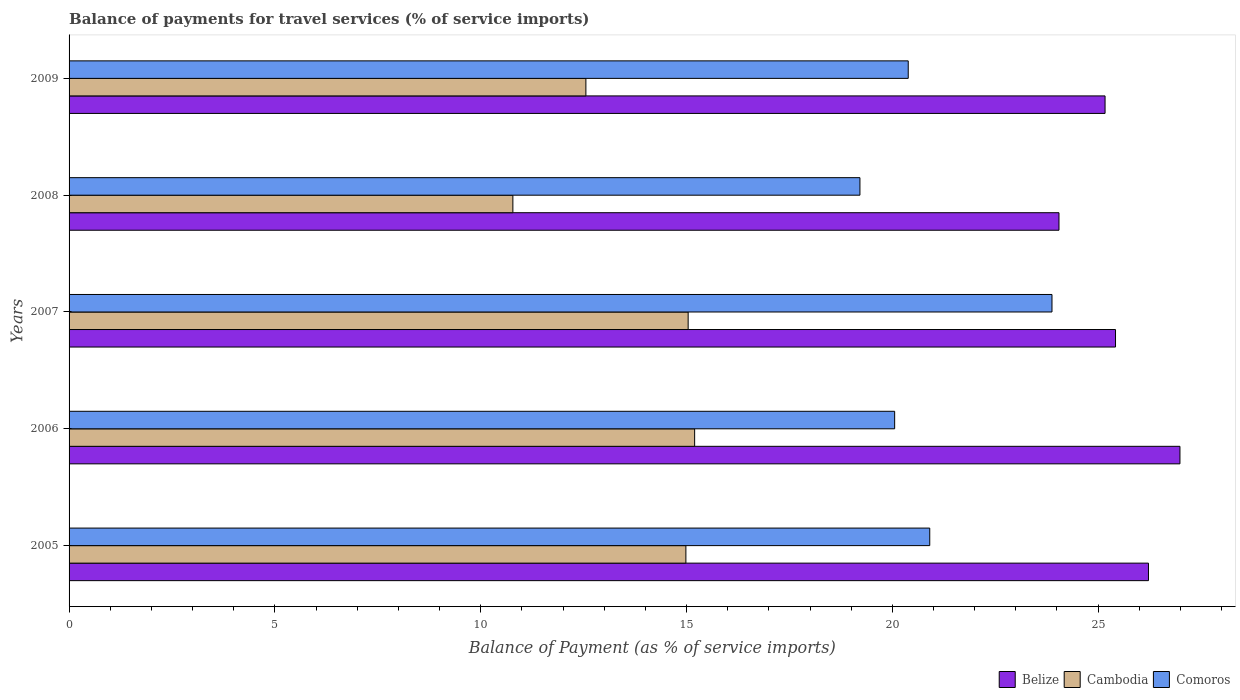Are the number of bars per tick equal to the number of legend labels?
Offer a terse response. Yes. Are the number of bars on each tick of the Y-axis equal?
Make the answer very short. Yes. How many bars are there on the 4th tick from the top?
Give a very brief answer. 3. What is the label of the 4th group of bars from the top?
Make the answer very short. 2006. What is the balance of payments for travel services in Comoros in 2006?
Keep it short and to the point. 20.06. Across all years, what is the maximum balance of payments for travel services in Belize?
Offer a very short reply. 26.99. Across all years, what is the minimum balance of payments for travel services in Belize?
Your response must be concise. 24.05. In which year was the balance of payments for travel services in Belize maximum?
Ensure brevity in your answer.  2006. What is the total balance of payments for travel services in Comoros in the graph?
Offer a very short reply. 104.44. What is the difference between the balance of payments for travel services in Cambodia in 2005 and that in 2009?
Provide a succinct answer. 2.43. What is the difference between the balance of payments for travel services in Cambodia in 2005 and the balance of payments for travel services in Belize in 2009?
Offer a terse response. -10.18. What is the average balance of payments for travel services in Belize per year?
Make the answer very short. 25.57. In the year 2008, what is the difference between the balance of payments for travel services in Comoros and balance of payments for travel services in Cambodia?
Offer a very short reply. 8.43. What is the ratio of the balance of payments for travel services in Belize in 2005 to that in 2009?
Provide a short and direct response. 1.04. Is the balance of payments for travel services in Comoros in 2005 less than that in 2008?
Your response must be concise. No. What is the difference between the highest and the second highest balance of payments for travel services in Cambodia?
Keep it short and to the point. 0.16. What is the difference between the highest and the lowest balance of payments for travel services in Cambodia?
Keep it short and to the point. 4.42. In how many years, is the balance of payments for travel services in Belize greater than the average balance of payments for travel services in Belize taken over all years?
Keep it short and to the point. 2. Is the sum of the balance of payments for travel services in Cambodia in 2006 and 2008 greater than the maximum balance of payments for travel services in Comoros across all years?
Your answer should be very brief. Yes. What does the 3rd bar from the top in 2007 represents?
Offer a very short reply. Belize. What does the 1st bar from the bottom in 2008 represents?
Ensure brevity in your answer.  Belize. Is it the case that in every year, the sum of the balance of payments for travel services in Cambodia and balance of payments for travel services in Comoros is greater than the balance of payments for travel services in Belize?
Your response must be concise. Yes. How many bars are there?
Make the answer very short. 15. Are all the bars in the graph horizontal?
Provide a short and direct response. Yes. What is the difference between two consecutive major ticks on the X-axis?
Provide a succinct answer. 5. Are the values on the major ticks of X-axis written in scientific E-notation?
Offer a terse response. No. Does the graph contain any zero values?
Give a very brief answer. No. How many legend labels are there?
Keep it short and to the point. 3. How are the legend labels stacked?
Keep it short and to the point. Horizontal. What is the title of the graph?
Your answer should be compact. Balance of payments for travel services (% of service imports). What is the label or title of the X-axis?
Your answer should be very brief. Balance of Payment (as % of service imports). What is the Balance of Payment (as % of service imports) of Belize in 2005?
Your answer should be compact. 26.22. What is the Balance of Payment (as % of service imports) of Cambodia in 2005?
Offer a terse response. 14.98. What is the Balance of Payment (as % of service imports) in Comoros in 2005?
Provide a short and direct response. 20.91. What is the Balance of Payment (as % of service imports) of Belize in 2006?
Your response must be concise. 26.99. What is the Balance of Payment (as % of service imports) of Cambodia in 2006?
Provide a succinct answer. 15.2. What is the Balance of Payment (as % of service imports) in Comoros in 2006?
Offer a very short reply. 20.06. What is the Balance of Payment (as % of service imports) of Belize in 2007?
Provide a short and direct response. 25.42. What is the Balance of Payment (as % of service imports) of Cambodia in 2007?
Your answer should be compact. 15.04. What is the Balance of Payment (as % of service imports) in Comoros in 2007?
Offer a terse response. 23.88. What is the Balance of Payment (as % of service imports) of Belize in 2008?
Give a very brief answer. 24.05. What is the Balance of Payment (as % of service imports) of Cambodia in 2008?
Ensure brevity in your answer.  10.78. What is the Balance of Payment (as % of service imports) of Comoros in 2008?
Your answer should be very brief. 19.21. What is the Balance of Payment (as % of service imports) in Belize in 2009?
Ensure brevity in your answer.  25.17. What is the Balance of Payment (as % of service imports) of Cambodia in 2009?
Make the answer very short. 12.56. What is the Balance of Payment (as % of service imports) of Comoros in 2009?
Provide a short and direct response. 20.39. Across all years, what is the maximum Balance of Payment (as % of service imports) of Belize?
Your response must be concise. 26.99. Across all years, what is the maximum Balance of Payment (as % of service imports) of Cambodia?
Your response must be concise. 15.2. Across all years, what is the maximum Balance of Payment (as % of service imports) of Comoros?
Provide a short and direct response. 23.88. Across all years, what is the minimum Balance of Payment (as % of service imports) of Belize?
Your answer should be very brief. 24.05. Across all years, what is the minimum Balance of Payment (as % of service imports) of Cambodia?
Your answer should be very brief. 10.78. Across all years, what is the minimum Balance of Payment (as % of service imports) in Comoros?
Offer a very short reply. 19.21. What is the total Balance of Payment (as % of service imports) in Belize in the graph?
Offer a terse response. 127.85. What is the total Balance of Payment (as % of service imports) in Cambodia in the graph?
Offer a terse response. 68.56. What is the total Balance of Payment (as % of service imports) in Comoros in the graph?
Provide a succinct answer. 104.44. What is the difference between the Balance of Payment (as % of service imports) of Belize in 2005 and that in 2006?
Keep it short and to the point. -0.76. What is the difference between the Balance of Payment (as % of service imports) in Cambodia in 2005 and that in 2006?
Offer a terse response. -0.21. What is the difference between the Balance of Payment (as % of service imports) of Comoros in 2005 and that in 2006?
Provide a short and direct response. 0.85. What is the difference between the Balance of Payment (as % of service imports) in Belize in 2005 and that in 2007?
Your answer should be compact. 0.8. What is the difference between the Balance of Payment (as % of service imports) of Cambodia in 2005 and that in 2007?
Your answer should be compact. -0.06. What is the difference between the Balance of Payment (as % of service imports) of Comoros in 2005 and that in 2007?
Provide a succinct answer. -2.97. What is the difference between the Balance of Payment (as % of service imports) in Belize in 2005 and that in 2008?
Your answer should be compact. 2.17. What is the difference between the Balance of Payment (as % of service imports) of Cambodia in 2005 and that in 2008?
Ensure brevity in your answer.  4.2. What is the difference between the Balance of Payment (as % of service imports) in Comoros in 2005 and that in 2008?
Offer a very short reply. 1.7. What is the difference between the Balance of Payment (as % of service imports) of Belize in 2005 and that in 2009?
Offer a very short reply. 1.05. What is the difference between the Balance of Payment (as % of service imports) in Cambodia in 2005 and that in 2009?
Your answer should be compact. 2.43. What is the difference between the Balance of Payment (as % of service imports) in Comoros in 2005 and that in 2009?
Keep it short and to the point. 0.52. What is the difference between the Balance of Payment (as % of service imports) in Belize in 2006 and that in 2007?
Provide a short and direct response. 1.57. What is the difference between the Balance of Payment (as % of service imports) in Cambodia in 2006 and that in 2007?
Keep it short and to the point. 0.16. What is the difference between the Balance of Payment (as % of service imports) in Comoros in 2006 and that in 2007?
Provide a succinct answer. -3.82. What is the difference between the Balance of Payment (as % of service imports) of Belize in 2006 and that in 2008?
Make the answer very short. 2.94. What is the difference between the Balance of Payment (as % of service imports) in Cambodia in 2006 and that in 2008?
Your response must be concise. 4.42. What is the difference between the Balance of Payment (as % of service imports) of Comoros in 2006 and that in 2008?
Your answer should be compact. 0.84. What is the difference between the Balance of Payment (as % of service imports) of Belize in 2006 and that in 2009?
Provide a succinct answer. 1.82. What is the difference between the Balance of Payment (as % of service imports) in Cambodia in 2006 and that in 2009?
Ensure brevity in your answer.  2.64. What is the difference between the Balance of Payment (as % of service imports) of Comoros in 2006 and that in 2009?
Make the answer very short. -0.33. What is the difference between the Balance of Payment (as % of service imports) in Belize in 2007 and that in 2008?
Offer a very short reply. 1.37. What is the difference between the Balance of Payment (as % of service imports) of Cambodia in 2007 and that in 2008?
Your response must be concise. 4.26. What is the difference between the Balance of Payment (as % of service imports) in Comoros in 2007 and that in 2008?
Offer a terse response. 4.67. What is the difference between the Balance of Payment (as % of service imports) of Belize in 2007 and that in 2009?
Your answer should be very brief. 0.25. What is the difference between the Balance of Payment (as % of service imports) in Cambodia in 2007 and that in 2009?
Your answer should be very brief. 2.48. What is the difference between the Balance of Payment (as % of service imports) of Comoros in 2007 and that in 2009?
Your answer should be very brief. 3.49. What is the difference between the Balance of Payment (as % of service imports) of Belize in 2008 and that in 2009?
Your response must be concise. -1.12. What is the difference between the Balance of Payment (as % of service imports) in Cambodia in 2008 and that in 2009?
Keep it short and to the point. -1.77. What is the difference between the Balance of Payment (as % of service imports) in Comoros in 2008 and that in 2009?
Offer a very short reply. -1.17. What is the difference between the Balance of Payment (as % of service imports) of Belize in 2005 and the Balance of Payment (as % of service imports) of Cambodia in 2006?
Provide a succinct answer. 11.03. What is the difference between the Balance of Payment (as % of service imports) in Belize in 2005 and the Balance of Payment (as % of service imports) in Comoros in 2006?
Offer a very short reply. 6.17. What is the difference between the Balance of Payment (as % of service imports) of Cambodia in 2005 and the Balance of Payment (as % of service imports) of Comoros in 2006?
Your answer should be very brief. -5.07. What is the difference between the Balance of Payment (as % of service imports) of Belize in 2005 and the Balance of Payment (as % of service imports) of Cambodia in 2007?
Your answer should be very brief. 11.18. What is the difference between the Balance of Payment (as % of service imports) in Belize in 2005 and the Balance of Payment (as % of service imports) in Comoros in 2007?
Make the answer very short. 2.34. What is the difference between the Balance of Payment (as % of service imports) in Cambodia in 2005 and the Balance of Payment (as % of service imports) in Comoros in 2007?
Offer a terse response. -8.89. What is the difference between the Balance of Payment (as % of service imports) in Belize in 2005 and the Balance of Payment (as % of service imports) in Cambodia in 2008?
Your response must be concise. 15.44. What is the difference between the Balance of Payment (as % of service imports) of Belize in 2005 and the Balance of Payment (as % of service imports) of Comoros in 2008?
Your answer should be compact. 7.01. What is the difference between the Balance of Payment (as % of service imports) in Cambodia in 2005 and the Balance of Payment (as % of service imports) in Comoros in 2008?
Give a very brief answer. -4.23. What is the difference between the Balance of Payment (as % of service imports) in Belize in 2005 and the Balance of Payment (as % of service imports) in Cambodia in 2009?
Give a very brief answer. 13.67. What is the difference between the Balance of Payment (as % of service imports) of Belize in 2005 and the Balance of Payment (as % of service imports) of Comoros in 2009?
Give a very brief answer. 5.84. What is the difference between the Balance of Payment (as % of service imports) in Cambodia in 2005 and the Balance of Payment (as % of service imports) in Comoros in 2009?
Your answer should be compact. -5.4. What is the difference between the Balance of Payment (as % of service imports) of Belize in 2006 and the Balance of Payment (as % of service imports) of Cambodia in 2007?
Your response must be concise. 11.95. What is the difference between the Balance of Payment (as % of service imports) in Belize in 2006 and the Balance of Payment (as % of service imports) in Comoros in 2007?
Provide a succinct answer. 3.11. What is the difference between the Balance of Payment (as % of service imports) of Cambodia in 2006 and the Balance of Payment (as % of service imports) of Comoros in 2007?
Ensure brevity in your answer.  -8.68. What is the difference between the Balance of Payment (as % of service imports) in Belize in 2006 and the Balance of Payment (as % of service imports) in Cambodia in 2008?
Your answer should be very brief. 16.21. What is the difference between the Balance of Payment (as % of service imports) in Belize in 2006 and the Balance of Payment (as % of service imports) in Comoros in 2008?
Your response must be concise. 7.77. What is the difference between the Balance of Payment (as % of service imports) of Cambodia in 2006 and the Balance of Payment (as % of service imports) of Comoros in 2008?
Give a very brief answer. -4.02. What is the difference between the Balance of Payment (as % of service imports) in Belize in 2006 and the Balance of Payment (as % of service imports) in Cambodia in 2009?
Ensure brevity in your answer.  14.43. What is the difference between the Balance of Payment (as % of service imports) in Belize in 2006 and the Balance of Payment (as % of service imports) in Comoros in 2009?
Your answer should be very brief. 6.6. What is the difference between the Balance of Payment (as % of service imports) in Cambodia in 2006 and the Balance of Payment (as % of service imports) in Comoros in 2009?
Ensure brevity in your answer.  -5.19. What is the difference between the Balance of Payment (as % of service imports) of Belize in 2007 and the Balance of Payment (as % of service imports) of Cambodia in 2008?
Make the answer very short. 14.64. What is the difference between the Balance of Payment (as % of service imports) of Belize in 2007 and the Balance of Payment (as % of service imports) of Comoros in 2008?
Ensure brevity in your answer.  6.21. What is the difference between the Balance of Payment (as % of service imports) in Cambodia in 2007 and the Balance of Payment (as % of service imports) in Comoros in 2008?
Offer a terse response. -4.17. What is the difference between the Balance of Payment (as % of service imports) in Belize in 2007 and the Balance of Payment (as % of service imports) in Cambodia in 2009?
Ensure brevity in your answer.  12.87. What is the difference between the Balance of Payment (as % of service imports) of Belize in 2007 and the Balance of Payment (as % of service imports) of Comoros in 2009?
Offer a terse response. 5.04. What is the difference between the Balance of Payment (as % of service imports) of Cambodia in 2007 and the Balance of Payment (as % of service imports) of Comoros in 2009?
Give a very brief answer. -5.35. What is the difference between the Balance of Payment (as % of service imports) in Belize in 2008 and the Balance of Payment (as % of service imports) in Cambodia in 2009?
Make the answer very short. 11.49. What is the difference between the Balance of Payment (as % of service imports) in Belize in 2008 and the Balance of Payment (as % of service imports) in Comoros in 2009?
Make the answer very short. 3.66. What is the difference between the Balance of Payment (as % of service imports) of Cambodia in 2008 and the Balance of Payment (as % of service imports) of Comoros in 2009?
Provide a succinct answer. -9.6. What is the average Balance of Payment (as % of service imports) of Belize per year?
Provide a succinct answer. 25.57. What is the average Balance of Payment (as % of service imports) of Cambodia per year?
Ensure brevity in your answer.  13.71. What is the average Balance of Payment (as % of service imports) in Comoros per year?
Offer a very short reply. 20.89. In the year 2005, what is the difference between the Balance of Payment (as % of service imports) in Belize and Balance of Payment (as % of service imports) in Cambodia?
Offer a very short reply. 11.24. In the year 2005, what is the difference between the Balance of Payment (as % of service imports) of Belize and Balance of Payment (as % of service imports) of Comoros?
Your answer should be compact. 5.31. In the year 2005, what is the difference between the Balance of Payment (as % of service imports) of Cambodia and Balance of Payment (as % of service imports) of Comoros?
Give a very brief answer. -5.92. In the year 2006, what is the difference between the Balance of Payment (as % of service imports) of Belize and Balance of Payment (as % of service imports) of Cambodia?
Keep it short and to the point. 11.79. In the year 2006, what is the difference between the Balance of Payment (as % of service imports) of Belize and Balance of Payment (as % of service imports) of Comoros?
Your response must be concise. 6.93. In the year 2006, what is the difference between the Balance of Payment (as % of service imports) of Cambodia and Balance of Payment (as % of service imports) of Comoros?
Provide a short and direct response. -4.86. In the year 2007, what is the difference between the Balance of Payment (as % of service imports) in Belize and Balance of Payment (as % of service imports) in Cambodia?
Your answer should be compact. 10.38. In the year 2007, what is the difference between the Balance of Payment (as % of service imports) of Belize and Balance of Payment (as % of service imports) of Comoros?
Your answer should be compact. 1.54. In the year 2007, what is the difference between the Balance of Payment (as % of service imports) of Cambodia and Balance of Payment (as % of service imports) of Comoros?
Keep it short and to the point. -8.84. In the year 2008, what is the difference between the Balance of Payment (as % of service imports) in Belize and Balance of Payment (as % of service imports) in Cambodia?
Ensure brevity in your answer.  13.27. In the year 2008, what is the difference between the Balance of Payment (as % of service imports) of Belize and Balance of Payment (as % of service imports) of Comoros?
Keep it short and to the point. 4.84. In the year 2008, what is the difference between the Balance of Payment (as % of service imports) of Cambodia and Balance of Payment (as % of service imports) of Comoros?
Your response must be concise. -8.43. In the year 2009, what is the difference between the Balance of Payment (as % of service imports) of Belize and Balance of Payment (as % of service imports) of Cambodia?
Your response must be concise. 12.61. In the year 2009, what is the difference between the Balance of Payment (as % of service imports) in Belize and Balance of Payment (as % of service imports) in Comoros?
Your response must be concise. 4.78. In the year 2009, what is the difference between the Balance of Payment (as % of service imports) in Cambodia and Balance of Payment (as % of service imports) in Comoros?
Provide a succinct answer. -7.83. What is the ratio of the Balance of Payment (as % of service imports) of Belize in 2005 to that in 2006?
Provide a short and direct response. 0.97. What is the ratio of the Balance of Payment (as % of service imports) in Comoros in 2005 to that in 2006?
Give a very brief answer. 1.04. What is the ratio of the Balance of Payment (as % of service imports) in Belize in 2005 to that in 2007?
Your answer should be very brief. 1.03. What is the ratio of the Balance of Payment (as % of service imports) in Cambodia in 2005 to that in 2007?
Your answer should be very brief. 1. What is the ratio of the Balance of Payment (as % of service imports) of Comoros in 2005 to that in 2007?
Provide a short and direct response. 0.88. What is the ratio of the Balance of Payment (as % of service imports) in Belize in 2005 to that in 2008?
Your answer should be compact. 1.09. What is the ratio of the Balance of Payment (as % of service imports) of Cambodia in 2005 to that in 2008?
Ensure brevity in your answer.  1.39. What is the ratio of the Balance of Payment (as % of service imports) of Comoros in 2005 to that in 2008?
Ensure brevity in your answer.  1.09. What is the ratio of the Balance of Payment (as % of service imports) of Belize in 2005 to that in 2009?
Your answer should be very brief. 1.04. What is the ratio of the Balance of Payment (as % of service imports) in Cambodia in 2005 to that in 2009?
Provide a short and direct response. 1.19. What is the ratio of the Balance of Payment (as % of service imports) in Comoros in 2005 to that in 2009?
Provide a succinct answer. 1.03. What is the ratio of the Balance of Payment (as % of service imports) of Belize in 2006 to that in 2007?
Your answer should be very brief. 1.06. What is the ratio of the Balance of Payment (as % of service imports) in Cambodia in 2006 to that in 2007?
Provide a short and direct response. 1.01. What is the ratio of the Balance of Payment (as % of service imports) of Comoros in 2006 to that in 2007?
Your answer should be compact. 0.84. What is the ratio of the Balance of Payment (as % of service imports) in Belize in 2006 to that in 2008?
Keep it short and to the point. 1.12. What is the ratio of the Balance of Payment (as % of service imports) of Cambodia in 2006 to that in 2008?
Keep it short and to the point. 1.41. What is the ratio of the Balance of Payment (as % of service imports) of Comoros in 2006 to that in 2008?
Your answer should be very brief. 1.04. What is the ratio of the Balance of Payment (as % of service imports) of Belize in 2006 to that in 2009?
Provide a succinct answer. 1.07. What is the ratio of the Balance of Payment (as % of service imports) in Cambodia in 2006 to that in 2009?
Provide a short and direct response. 1.21. What is the ratio of the Balance of Payment (as % of service imports) of Comoros in 2006 to that in 2009?
Ensure brevity in your answer.  0.98. What is the ratio of the Balance of Payment (as % of service imports) of Belize in 2007 to that in 2008?
Give a very brief answer. 1.06. What is the ratio of the Balance of Payment (as % of service imports) of Cambodia in 2007 to that in 2008?
Ensure brevity in your answer.  1.4. What is the ratio of the Balance of Payment (as % of service imports) of Comoros in 2007 to that in 2008?
Make the answer very short. 1.24. What is the ratio of the Balance of Payment (as % of service imports) in Cambodia in 2007 to that in 2009?
Offer a terse response. 1.2. What is the ratio of the Balance of Payment (as % of service imports) of Comoros in 2007 to that in 2009?
Make the answer very short. 1.17. What is the ratio of the Balance of Payment (as % of service imports) of Belize in 2008 to that in 2009?
Your answer should be very brief. 0.96. What is the ratio of the Balance of Payment (as % of service imports) of Cambodia in 2008 to that in 2009?
Make the answer very short. 0.86. What is the ratio of the Balance of Payment (as % of service imports) in Comoros in 2008 to that in 2009?
Provide a short and direct response. 0.94. What is the difference between the highest and the second highest Balance of Payment (as % of service imports) of Belize?
Provide a succinct answer. 0.76. What is the difference between the highest and the second highest Balance of Payment (as % of service imports) of Cambodia?
Give a very brief answer. 0.16. What is the difference between the highest and the second highest Balance of Payment (as % of service imports) of Comoros?
Provide a succinct answer. 2.97. What is the difference between the highest and the lowest Balance of Payment (as % of service imports) in Belize?
Ensure brevity in your answer.  2.94. What is the difference between the highest and the lowest Balance of Payment (as % of service imports) in Cambodia?
Provide a short and direct response. 4.42. What is the difference between the highest and the lowest Balance of Payment (as % of service imports) of Comoros?
Provide a short and direct response. 4.67. 